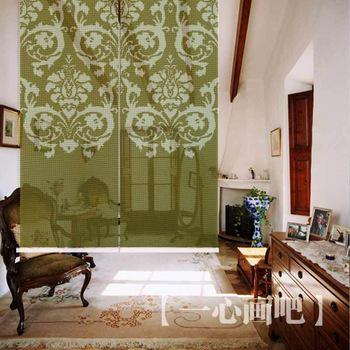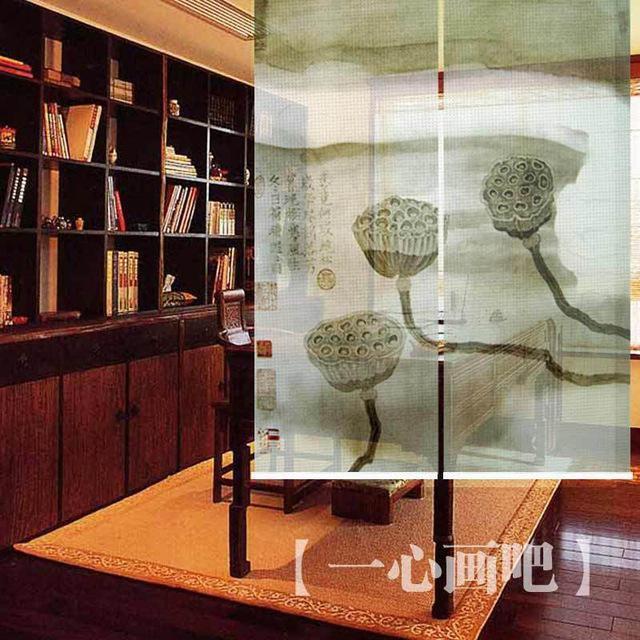The first image is the image on the left, the second image is the image on the right. Examine the images to the left and right. Is the description "An image with a tall lamp at the right includes at least three beige window shades with the upper part of the windows uncovered." accurate? Answer yes or no. No. The first image is the image on the left, the second image is the image on the right. Assess this claim about the two images: "The left and right image contains a total of five windows raised off the floor.". Correct or not? Answer yes or no. No. 